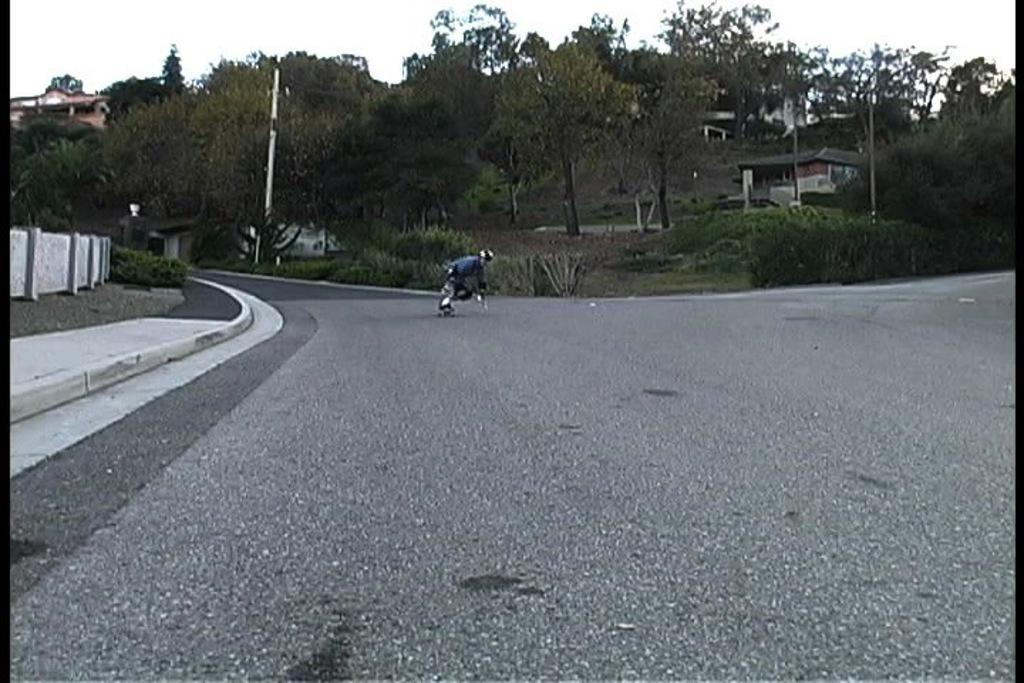What activity is the person in the image engaged in? The person is doing skating on the road. What objects can be seen in the image besides the person? There are poles, houses, and trees in the image. What is visible in the background of the image? The sky is visible in the background of the image. What type of pencil is the person using to skate in the image? There is no pencil present in the image; the person is skating on the road using skates. 